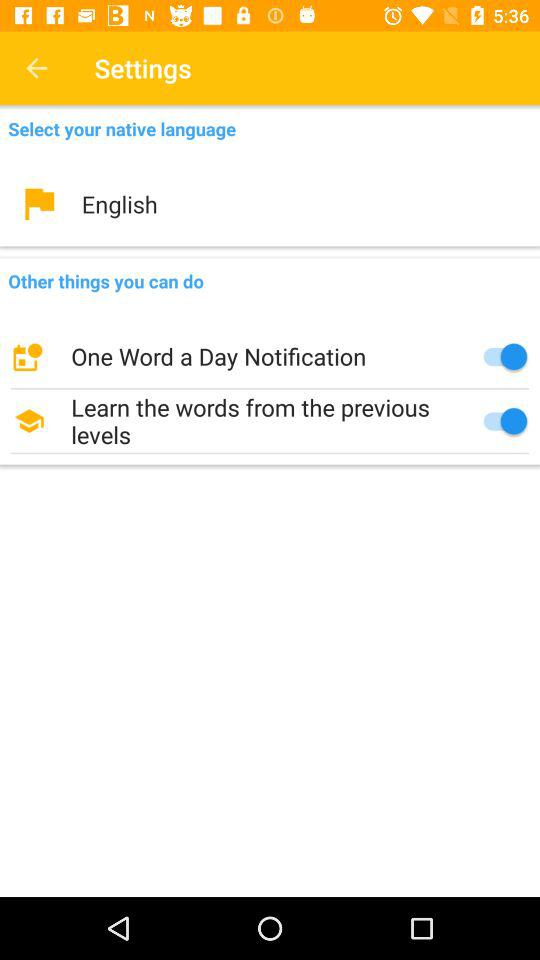How many items are there in the Other things you can do section?
Answer the question using a single word or phrase. 2 